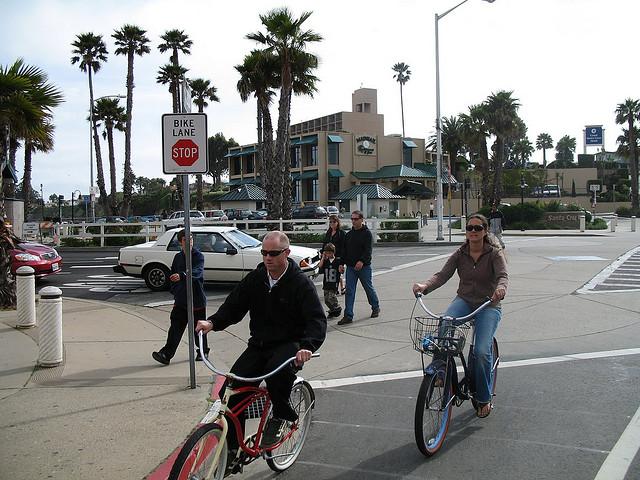Who is supposed to stop?
Keep it brief. Cars. Is there a bike lane for bikers?
Short answer required. Yes. How many trees are there?
Write a very short answer. 16. Is that a stop sign?
Concise answer only. Yes. What kind of trees are growing here?
Short answer required. Palm. 